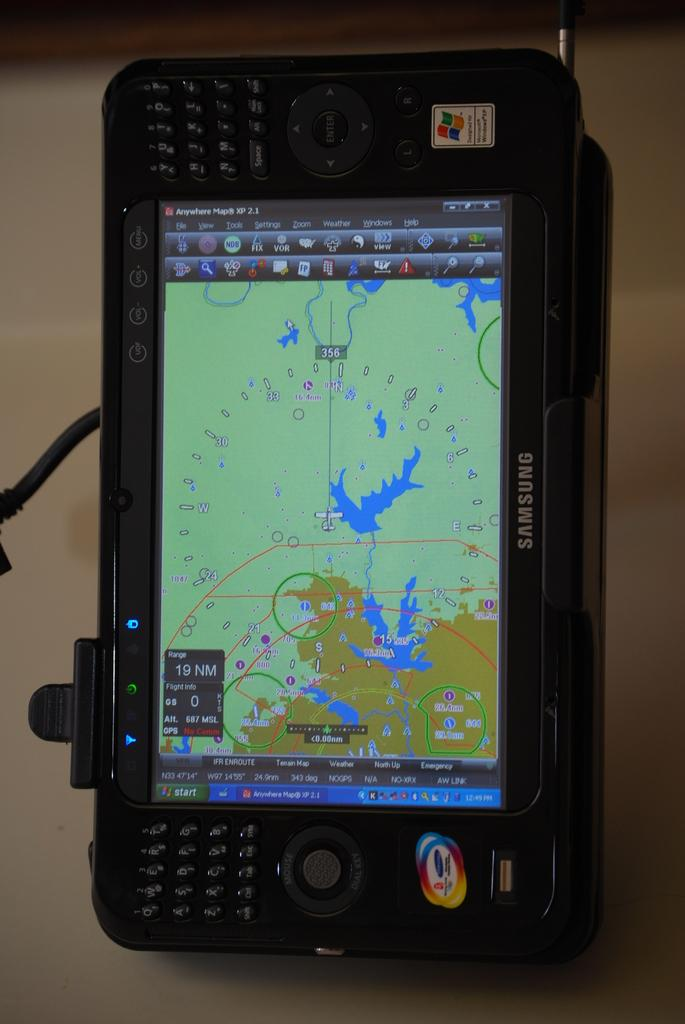<image>
Summarize the visual content of the image. A Samsung electronic device shows a map and coordinates on screen. 